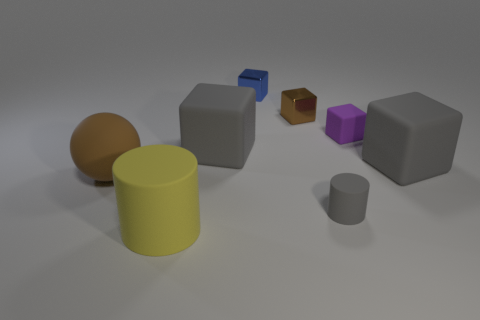Are there more small matte objects that are in front of the small matte block than cylinders?
Your answer should be compact. No. What material is the small thing that is in front of the brown thing on the left side of the object in front of the tiny gray rubber object?
Offer a terse response. Rubber. What number of things are small gray objects or large things that are right of the yellow matte object?
Offer a very short reply. 3. Does the thing in front of the small gray matte object have the same color as the large rubber ball?
Your response must be concise. No. Are there more gray blocks that are to the right of the tiny blue cube than things that are behind the brown shiny object?
Provide a short and direct response. No. Is there anything else that has the same color as the tiny cylinder?
Give a very brief answer. Yes. What number of objects are either tiny gray objects or purple matte things?
Provide a short and direct response. 2. There is a gray cube right of the blue cube; is it the same size as the blue shiny cube?
Offer a terse response. No. What number of other things are there of the same size as the blue shiny object?
Offer a very short reply. 3. Are there any big red things?
Ensure brevity in your answer.  No. 